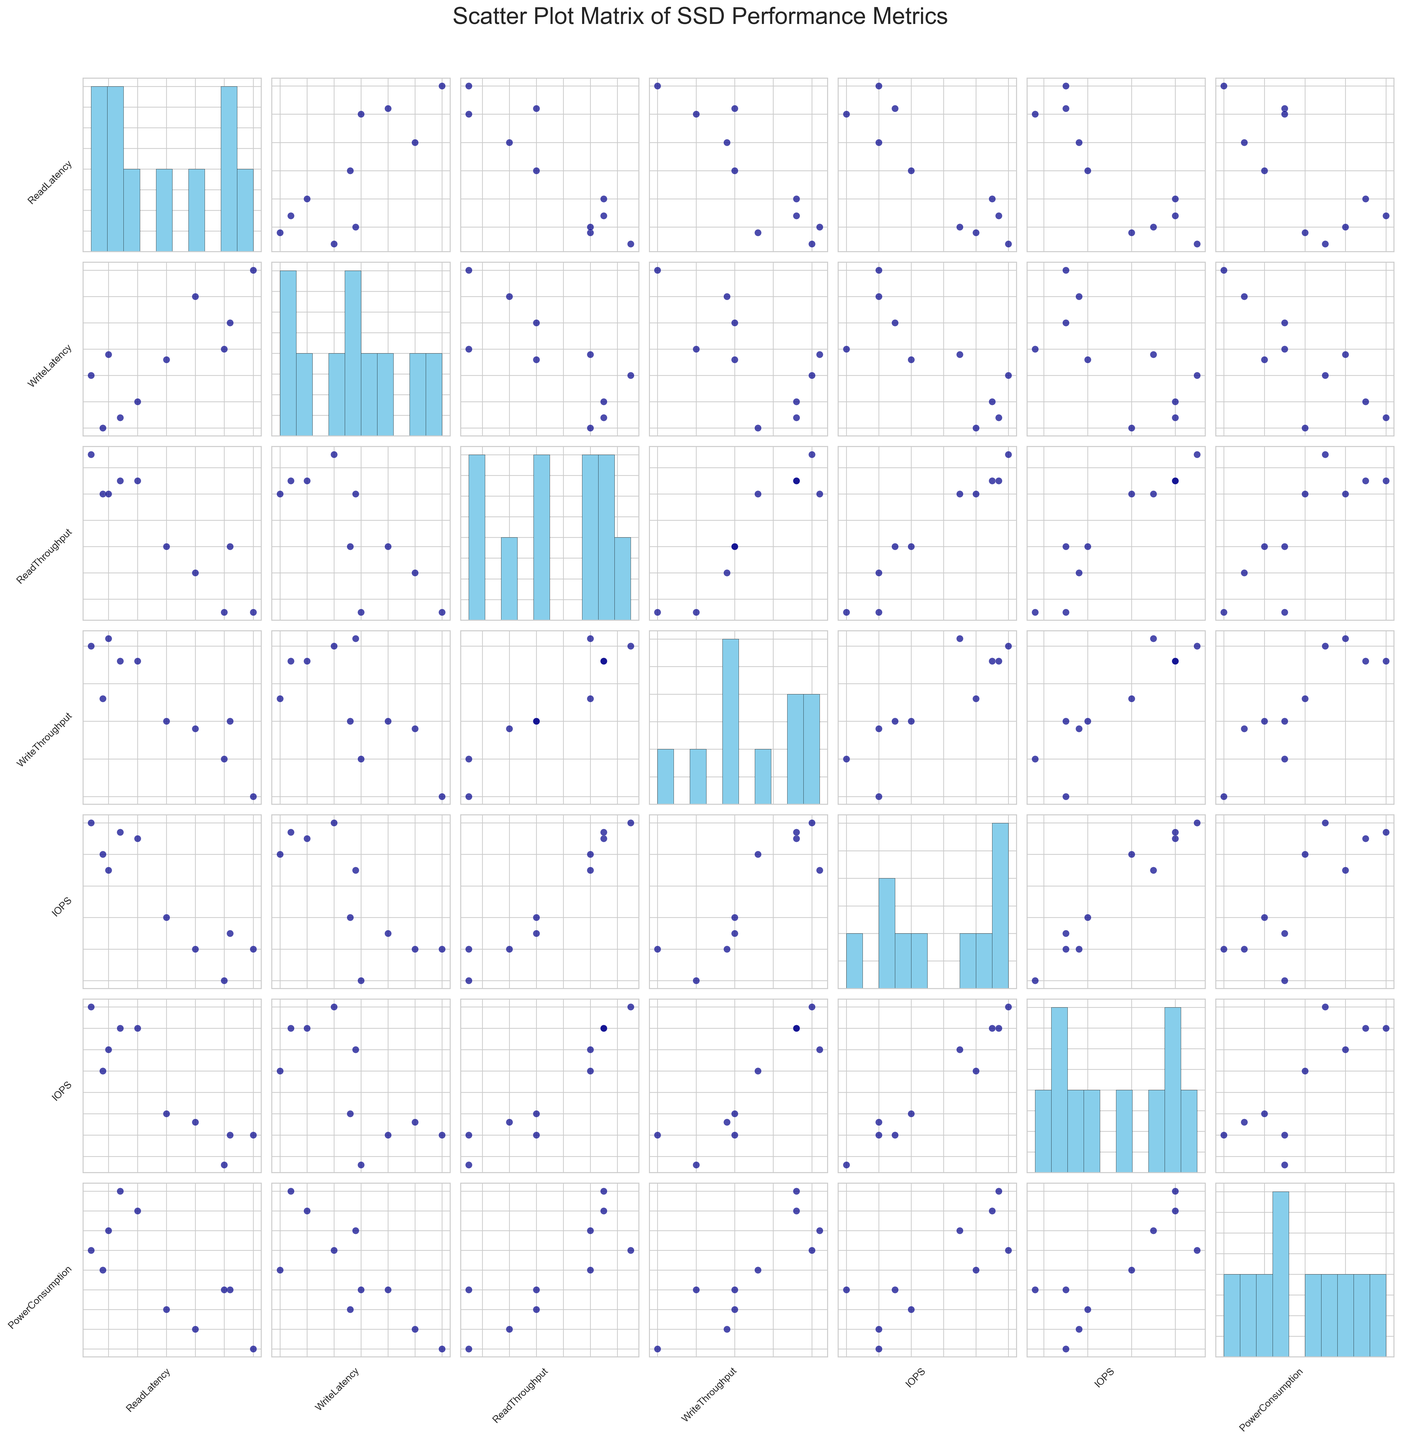what is the range of read latency values (in nanoseconds) among the SSD models? The read latency values can be identified by looking at the scatter plots and histograms corresponding to ReadLatency(ns). Visual inspection shows values ranging from the lowest to the highest.
Answer: 72 to 100 ns which SSD model has the highest read throughput (in MB/s)? By observing the scatter plot or histogram corresponding to ReadThroughput(MB/s), we can identify the data point with the maximum read throughput.
Answer: Seagate FireCuda 530 is there a noticeable correlation between power consumption and IOPS (random read)? To determine correlation, observe the scatter plot of PowerConsumption(W) vs. IOPS(RandomRead). Visual assessment indicates a pattern or lack thereof in the data points.
Answer: Yes, there seems to be a positive correlation how does the read latency correlate with write latency across different SSD models? Check the scatter plot for ReadLatency(ns) vs. WriteLatency(ns). Observing the spread and shape of data points will indicate if there is any apparent correlation, positive or negative.
Answer: Positive correlation which two SSD models have almost the same write throughput but noticeably different power consumption? Look at the scatter plot of WriteThroughput(MB/s) vs. PowerConsumption(W). Identify pairs of points aligned horizontally but with significant vertical separation.
Answer: Sabrent Rocket  4 Plus, Corsair MP600 Pro XT 